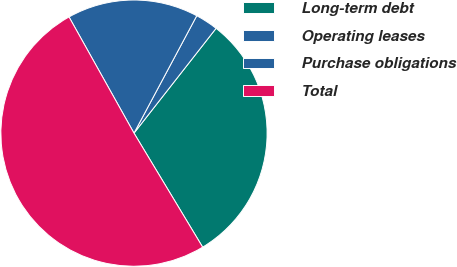Convert chart. <chart><loc_0><loc_0><loc_500><loc_500><pie_chart><fcel>Long-term debt<fcel>Operating leases<fcel>Purchase obligations<fcel>Total<nl><fcel>30.8%<fcel>2.76%<fcel>15.93%<fcel>50.51%<nl></chart> 